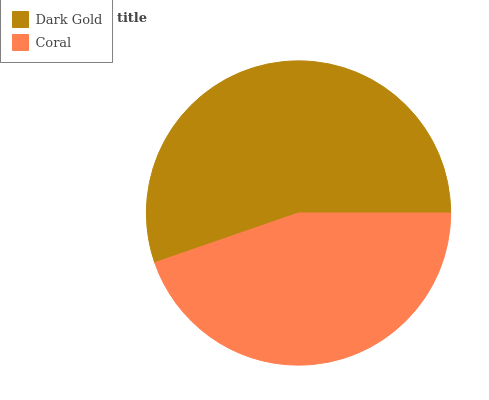Is Coral the minimum?
Answer yes or no. Yes. Is Dark Gold the maximum?
Answer yes or no. Yes. Is Coral the maximum?
Answer yes or no. No. Is Dark Gold greater than Coral?
Answer yes or no. Yes. Is Coral less than Dark Gold?
Answer yes or no. Yes. Is Coral greater than Dark Gold?
Answer yes or no. No. Is Dark Gold less than Coral?
Answer yes or no. No. Is Dark Gold the high median?
Answer yes or no. Yes. Is Coral the low median?
Answer yes or no. Yes. Is Coral the high median?
Answer yes or no. No. Is Dark Gold the low median?
Answer yes or no. No. 